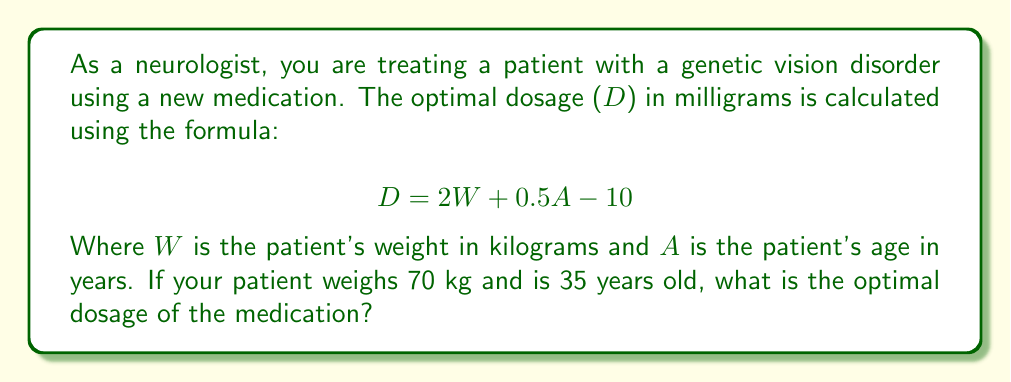Provide a solution to this math problem. To solve this problem, we'll follow these steps:

1. Identify the given information:
   - Patient's weight (W) = 70 kg
   - Patient's age (A) = 35 years
   - Formula: $D = 2W + 0.5A - 10$

2. Substitute the values into the formula:
   $$ D = 2(70) + 0.5(35) - 10 $$

3. Calculate the first term:
   $$ D = 140 + 0.5(35) - 10 $$

4. Calculate the second term:
   $$ D = 140 + 17.5 - 10 $$

5. Perform the final subtraction:
   $$ D = 157.5 - 10 = 147.5 $$

Therefore, the optimal dosage for this patient is 147.5 mg.
Answer: 147.5 mg 